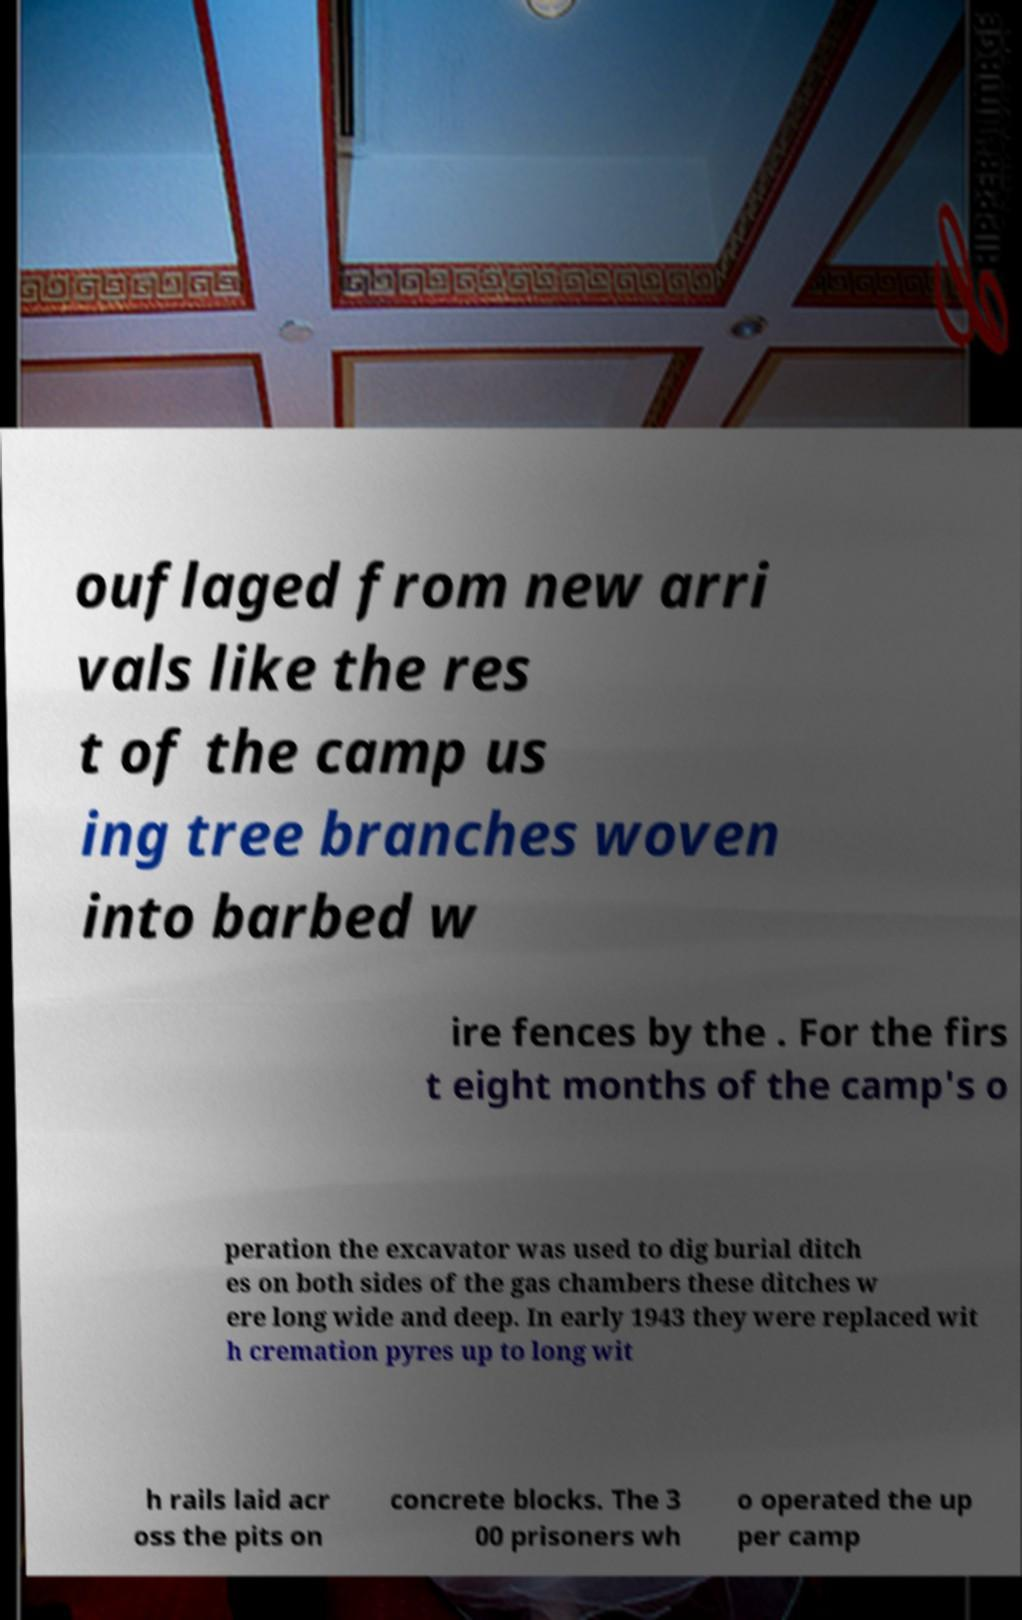I need the written content from this picture converted into text. Can you do that? ouflaged from new arri vals like the res t of the camp us ing tree branches woven into barbed w ire fences by the . For the firs t eight months of the camp's o peration the excavator was used to dig burial ditch es on both sides of the gas chambers these ditches w ere long wide and deep. In early 1943 they were replaced wit h cremation pyres up to long wit h rails laid acr oss the pits on concrete blocks. The 3 00 prisoners wh o operated the up per camp 